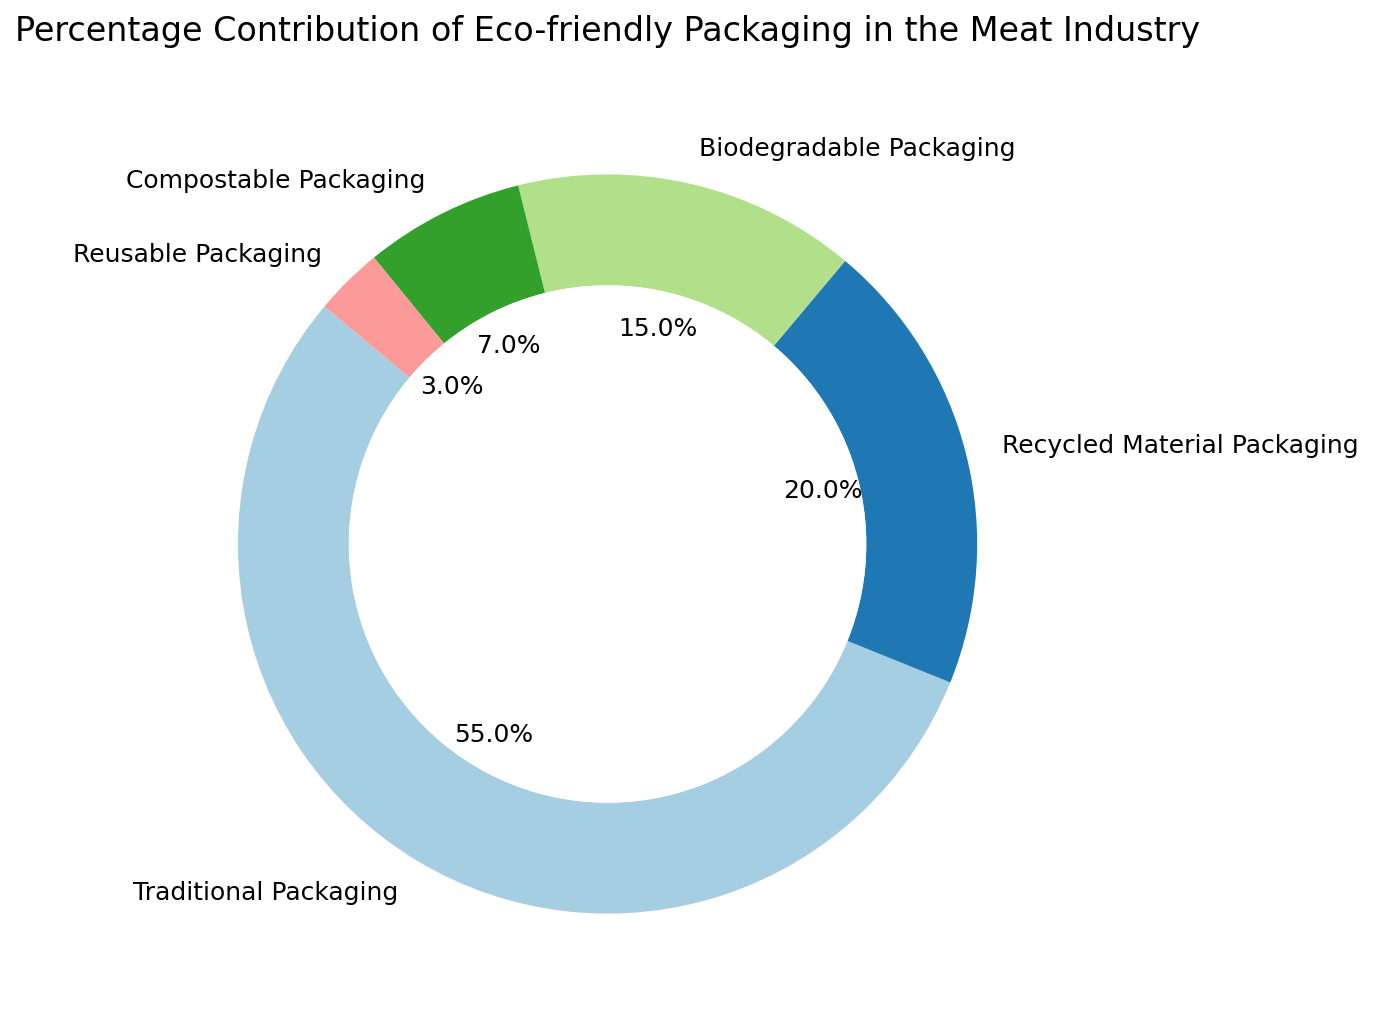What percentage of packaging is recyclable (sum of Recycled Material Packaging and Reusable Packaging)? First, identify the percentages for recyclable options: Recycled Material Packaging (20) and Reusable Packaging (3). Add these percentages together: 20 + 3 = 23.
Answer: 23% Which category has the smallest contribution? Locate the category with the smallest numerical slice in the chart. The Reusable Packaging has the smallest percentage at 3%.
Answer: Reusable Packaging How much more percentage does Traditional Packaging contribute compared to Biodegradable Packaging? Identify the percentages: Traditional Packaging (55), Biodegradable Packaging (15). Subtract the smaller from the larger: 55 - 15 = 40.
Answer: 40 Which two categories combined make up a greater percentage than Traditional Packaging alone? Check the combinations: Recycled Material Packaging (20) + Biodegradable Packaging (15) = 35, Recycled Material Packaging (20) + Compostable Packaging (7) = 27, etc. The combination Biodegradable Packaging + Compostable Packaging + Reusable Packaging = 15 + 7 + 3 = 25 does not exceed, only Recycled Material Packaging (20) and Biodegradable Packaging (15) = 35 exceed Traditional Packaging (55) on comparison.
Answer: None What is the difference between the sum of eco-friendly packaging options and Traditional Packaging? Sum the eco-friendly categories: Recycled Material Packaging (20), Biodegradable Packaging (15), Compostable Packaging (7), Reusable Packaging (3). So, 20 + 15 + 7 + 3 = 45. Now subtract the percentage of Traditional Packaging (55): 55 - 45 = 10.
Answer: 10 Which category is second in percentage after Traditional Packaging? Identify the highest percentage (55% for Traditional Packaging) and then find the second highest. Recycled Material Packaging is 20%, bested only by Traditional Packaging.
Answer: Recycled Material Packaging If we combine the percentages of Biodegradable and Compostable Packaging, is it more than that of Recycled Material Packaging? Sum Biodegradable and Compostable Packaging: 15 + 7 = 22. Compare this to Recycled Material Packaging (20). Since 22 > 20, the combination is indeed more.
Answer: Yes Is the contribution of Compostable Packaging more than Reusable Packaging? Compare the percentages directly: Compostable Packaging (7) and Reusable Packaging (3). Since 7 > 3, Compostable Packaging has a higher contribution.
Answer: Yes What is the combined percentage contribution of Compostable and Reusable Packaging? Add the percentages: Compostable Packaging (7) + Reusable Packaging (3). 7 + 3 = 10.
Answer: 10% 